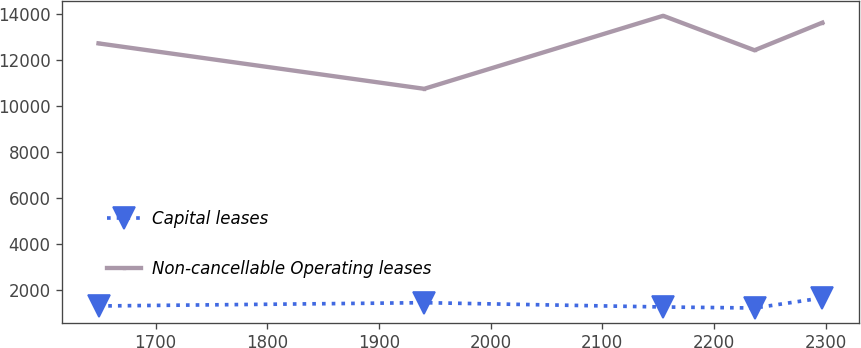<chart> <loc_0><loc_0><loc_500><loc_500><line_chart><ecel><fcel>Capital leases<fcel>Non-cancellable Operating leases<nl><fcel>1648.95<fcel>1285.59<fcel>12717.4<nl><fcel>1940.54<fcel>1429.09<fcel>10739.8<nl><fcel>2154.51<fcel>1241.79<fcel>13918.8<nl><fcel>2236.29<fcel>1197.99<fcel>12418.7<nl><fcel>2297.02<fcel>1635.95<fcel>13620.1<nl></chart> 